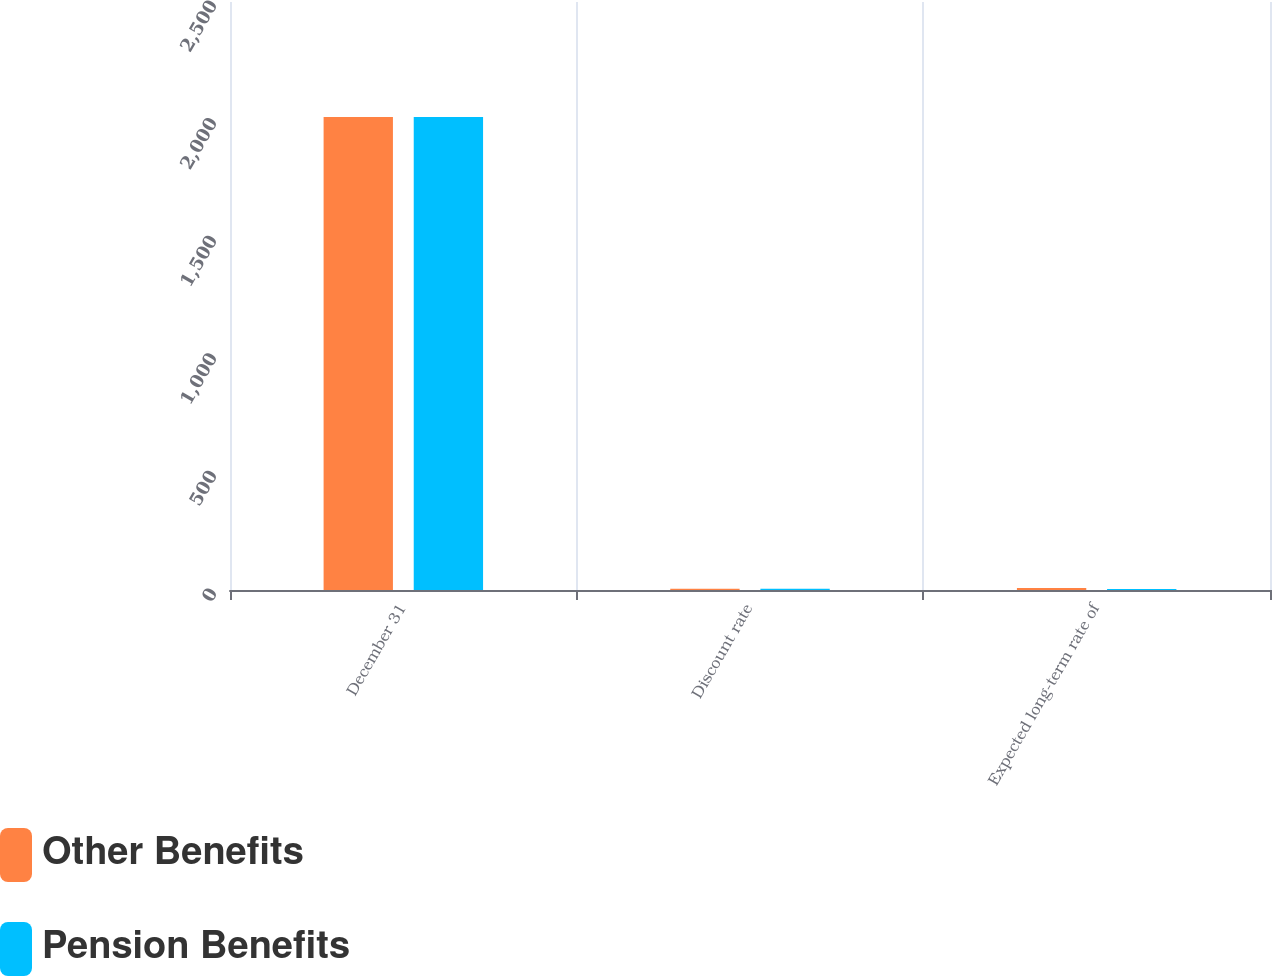Convert chart. <chart><loc_0><loc_0><loc_500><loc_500><stacked_bar_chart><ecel><fcel>December 31<fcel>Discount rate<fcel>Expected long-term rate of<nl><fcel>Other Benefits<fcel>2011<fcel>5.5<fcel>8.25<nl><fcel>Pension Benefits<fcel>2011<fcel>5.25<fcel>4.75<nl></chart> 